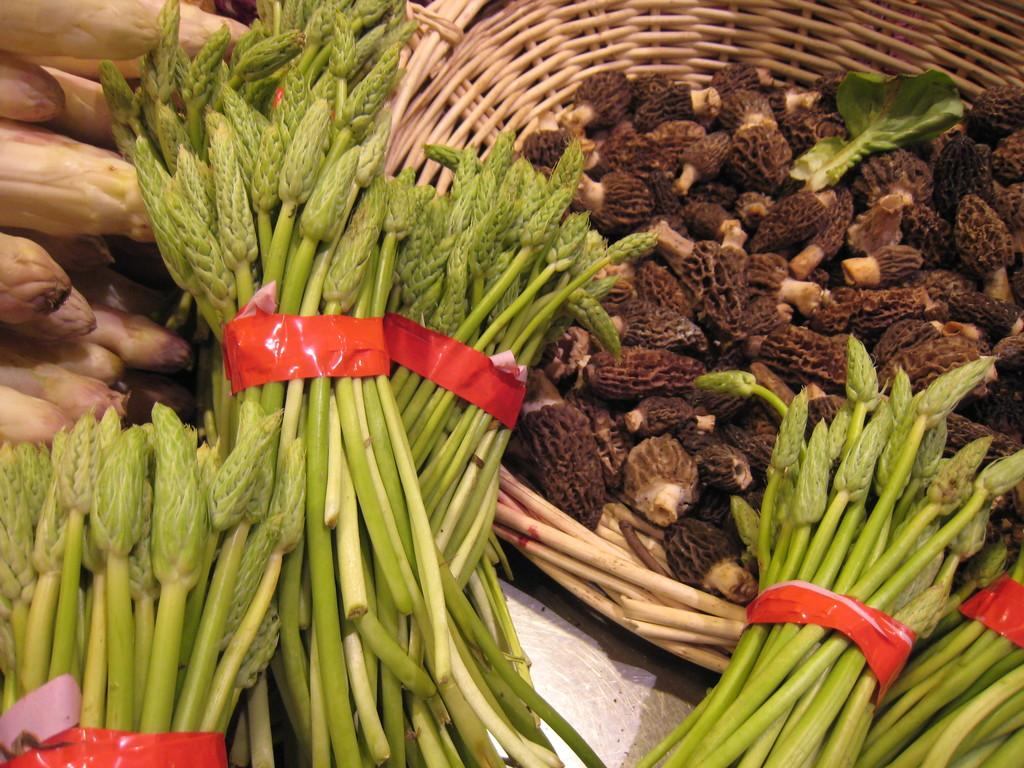What type of food is visible in the image? There are leafy vegetables in the image. Where are the leafy vegetables located in the image? The leafy vegetables are in the front of the image. What can be seen on the right side of the image? There is a basket on the right side of the image. What is inside the basket? There are vegetables present in the basket. What type of rail can be seen in the image? There is no rail present in the image. Can you describe the group of people interacting with the vegetables in the image? There are no people present in the image; it only features leafy vegetables, a basket, and vegetables in the basket. 